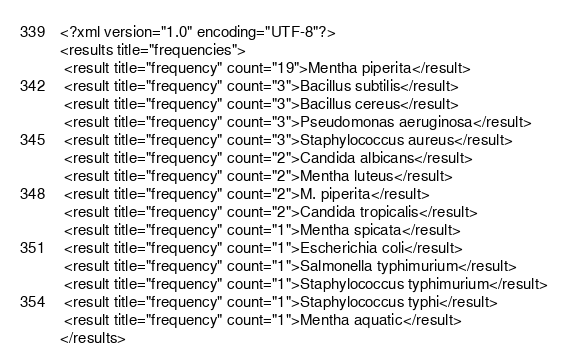Convert code to text. <code><loc_0><loc_0><loc_500><loc_500><_XML_><?xml version="1.0" encoding="UTF-8"?>
<results title="frequencies">
 <result title="frequency" count="19">Mentha piperita</result>
 <result title="frequency" count="3">Bacillus subtilis</result>
 <result title="frequency" count="3">Bacillus cereus</result>
 <result title="frequency" count="3">Pseudomonas aeruginosa</result>
 <result title="frequency" count="3">Staphylococcus aureus</result>
 <result title="frequency" count="2">Candida albicans</result>
 <result title="frequency" count="2">Mentha luteus</result>
 <result title="frequency" count="2">M. piperita</result>
 <result title="frequency" count="2">Candida tropicalis</result>
 <result title="frequency" count="1">Mentha spicata</result>
 <result title="frequency" count="1">Escherichia coli</result>
 <result title="frequency" count="1">Salmonella typhimurium</result>
 <result title="frequency" count="1">Staphylococcus typhimurium</result>
 <result title="frequency" count="1">Staphylococcus typhi</result>
 <result title="frequency" count="1">Mentha aquatic</result>
</results>
</code> 